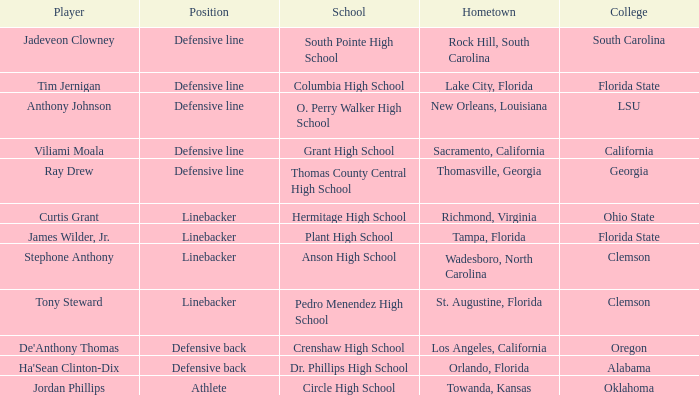Which college is Jordan Phillips playing for? Oklahoma. 